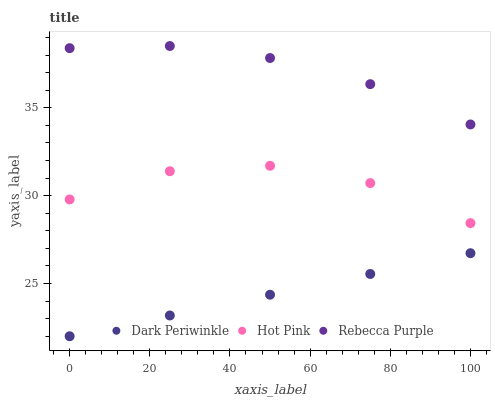Does Dark Periwinkle have the minimum area under the curve?
Answer yes or no. Yes. Does Rebecca Purple have the maximum area under the curve?
Answer yes or no. Yes. Does Rebecca Purple have the minimum area under the curve?
Answer yes or no. No. Does Dark Periwinkle have the maximum area under the curve?
Answer yes or no. No. Is Dark Periwinkle the smoothest?
Answer yes or no. Yes. Is Hot Pink the roughest?
Answer yes or no. Yes. Is Rebecca Purple the smoothest?
Answer yes or no. No. Is Rebecca Purple the roughest?
Answer yes or no. No. Does Dark Periwinkle have the lowest value?
Answer yes or no. Yes. Does Rebecca Purple have the lowest value?
Answer yes or no. No. Does Rebecca Purple have the highest value?
Answer yes or no. Yes. Does Dark Periwinkle have the highest value?
Answer yes or no. No. Is Dark Periwinkle less than Rebecca Purple?
Answer yes or no. Yes. Is Rebecca Purple greater than Hot Pink?
Answer yes or no. Yes. Does Dark Periwinkle intersect Rebecca Purple?
Answer yes or no. No. 